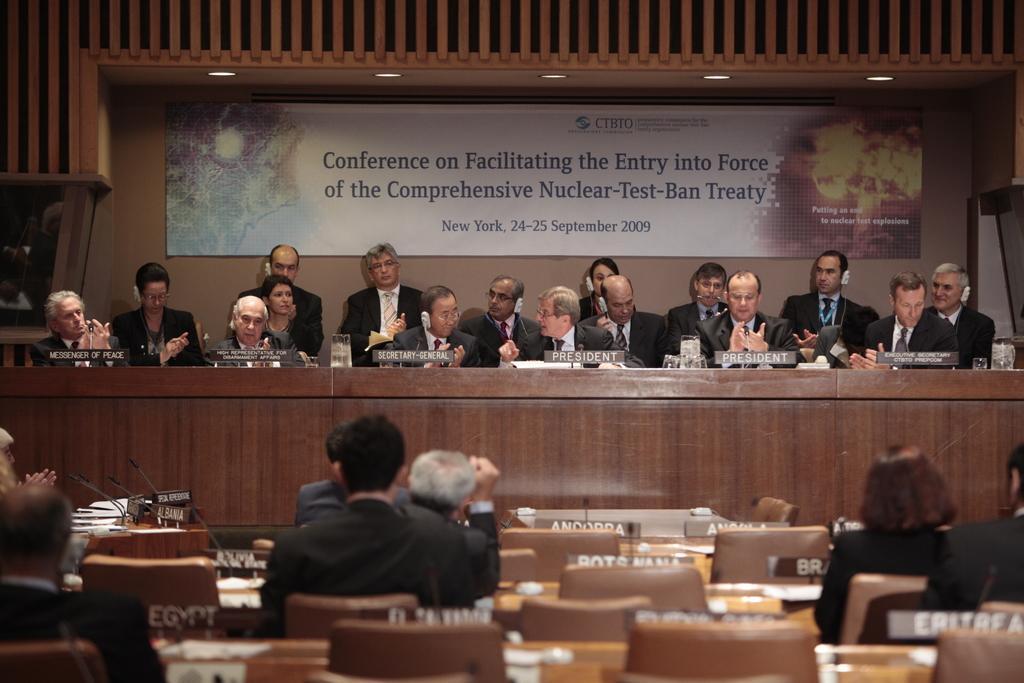Can you describe this image briefly? This image is taken inside a conference room. There are many people in this room. At the top the of the image there is a board with text. In the left side of the image there is a man sitting on a chair. In the middle of the image there are few empty chairs and a man sitting on a chair. In the left side of the image there is a table which has papers and mics on it. In the right side of the image two people are sitting on a chair. In the middle of the image there is a table with name boards and a glass with water. 